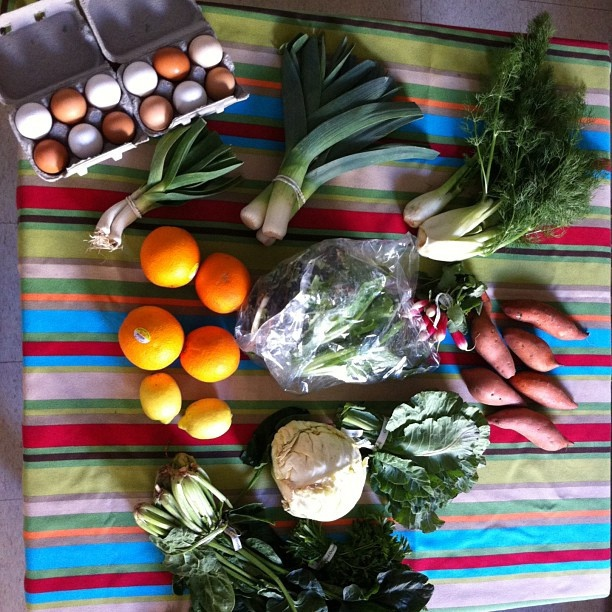Describe the objects in this image and their specific colors. I can see orange in darkgreen, brown, orange, gold, and red tones, orange in darkgreen, brown, red, orange, and gold tones, orange in darkgreen, red, brown, gold, and orange tones, orange in darkgreen, red, brown, and orange tones, and orange in darkgreen, red, gold, orange, and khaki tones in this image. 